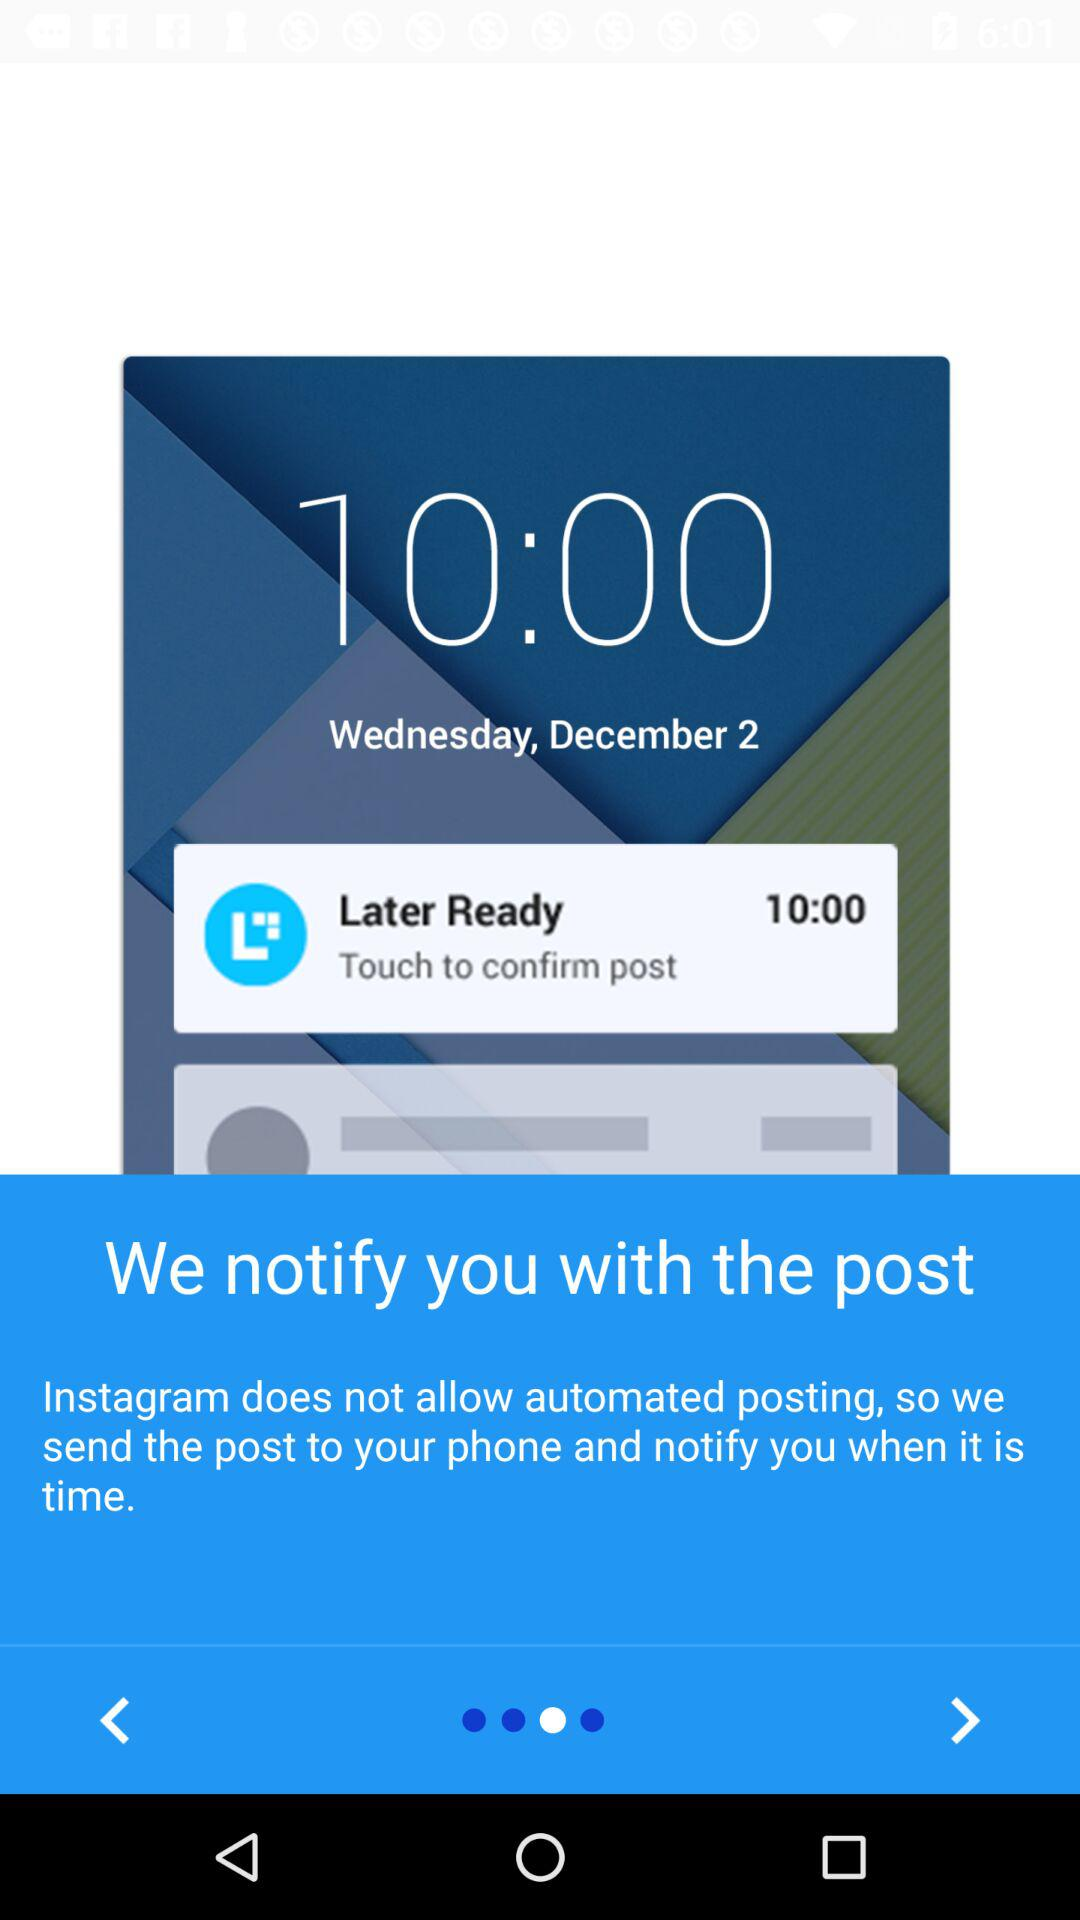What is the date? The date is Wednesday, December 2. 